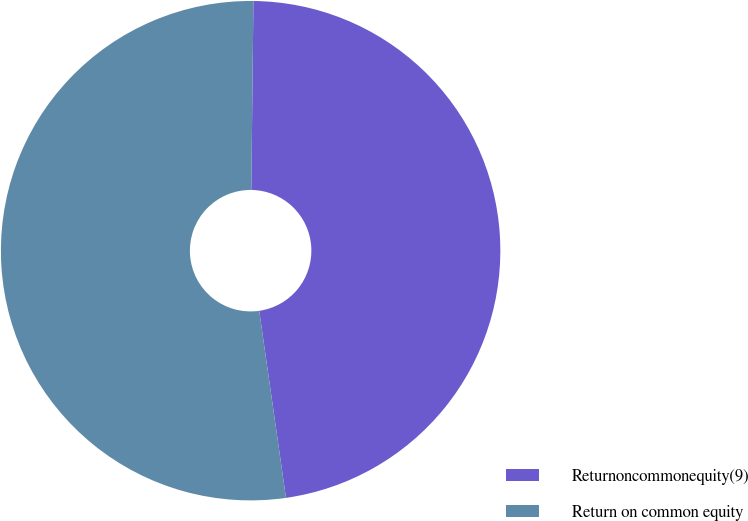<chart> <loc_0><loc_0><loc_500><loc_500><pie_chart><fcel>Returnoncommonequity(9)<fcel>Return on common equity<nl><fcel>47.56%<fcel>52.44%<nl></chart> 